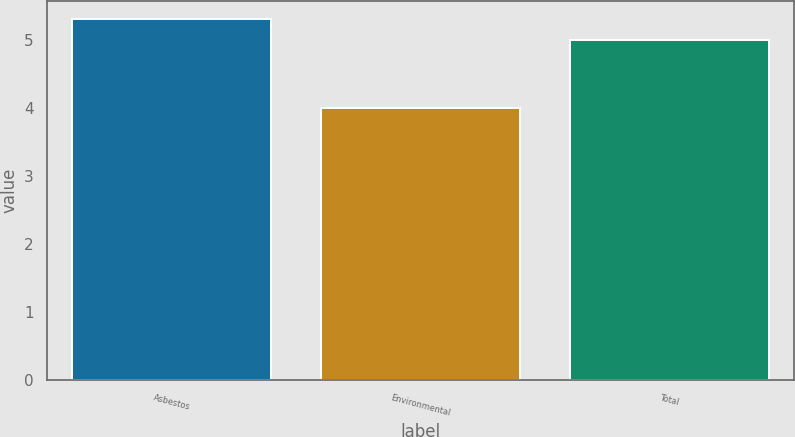<chart> <loc_0><loc_0><loc_500><loc_500><bar_chart><fcel>Asbestos<fcel>Environmental<fcel>Total<nl><fcel>5.3<fcel>4<fcel>5<nl></chart> 